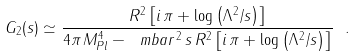<formula> <loc_0><loc_0><loc_500><loc_500>G _ { 2 } ( s ) \simeq \frac { R ^ { 2 } \left [ i \, \pi + \log \left ( \Lambda ^ { 2 } / s \right ) \right ] } { 4 \pi \, M _ { P l } ^ { 4 } - \ m b a r ^ { 2 } \, s \, R ^ { 2 } \left [ i \, \pi + \log \left ( \Lambda ^ { 2 } / s \right ) \right ] } \ .</formula> 